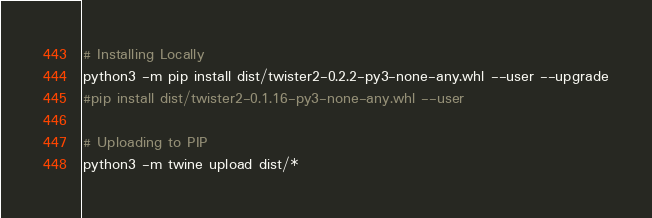Convert code to text. <code><loc_0><loc_0><loc_500><loc_500><_Bash_>
# Installing Locally
python3 -m pip install dist/twister2-0.2.2-py3-none-any.whl --user --upgrade
#pip install dist/twister2-0.1.16-py3-none-any.whl --user

# Uploading to PIP
python3 -m twine upload dist/*
</code> 